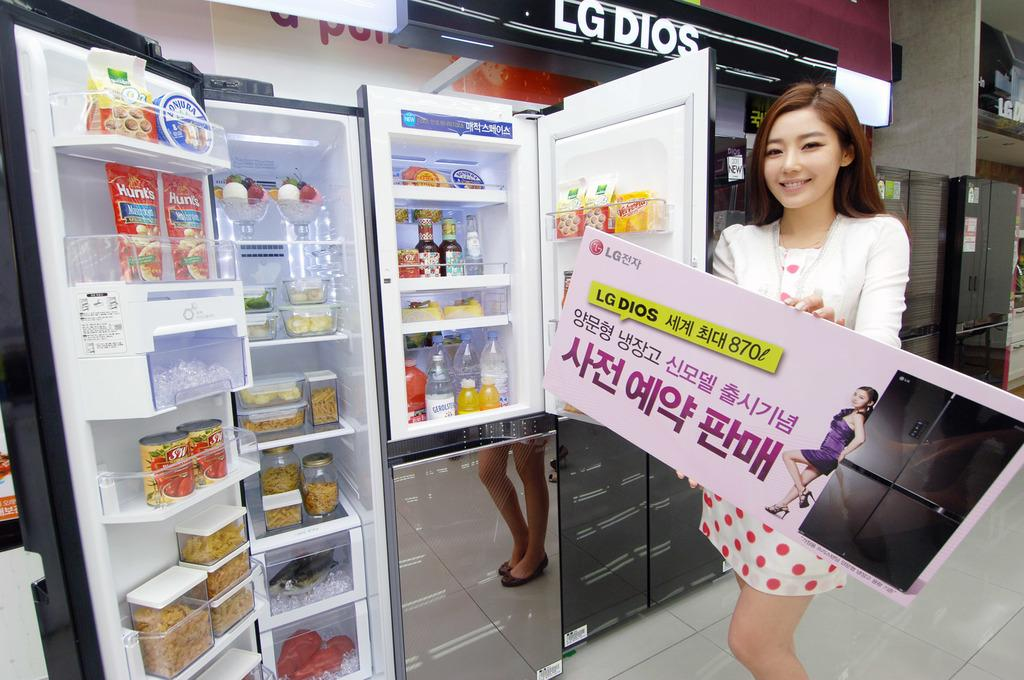<image>
Summarize the visual content of the image. A woman displaying a refrigerator for sale in a store. 